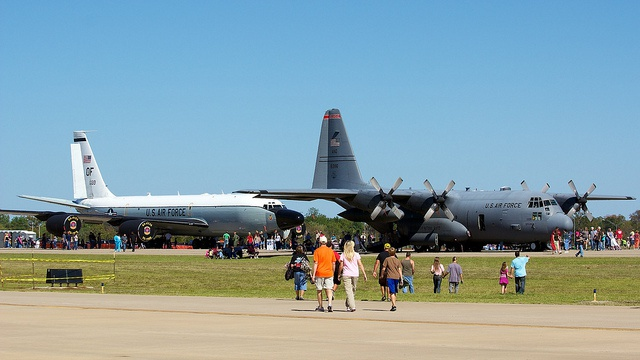Describe the objects in this image and their specific colors. I can see airplane in lightblue, black, gray, and darkgray tones, airplane in lightblue, black, white, and gray tones, people in lightblue, black, gray, darkgreen, and darkgray tones, people in lightblue, lightgray, and tan tones, and people in lightblue, red, orange, ivory, and gray tones in this image. 